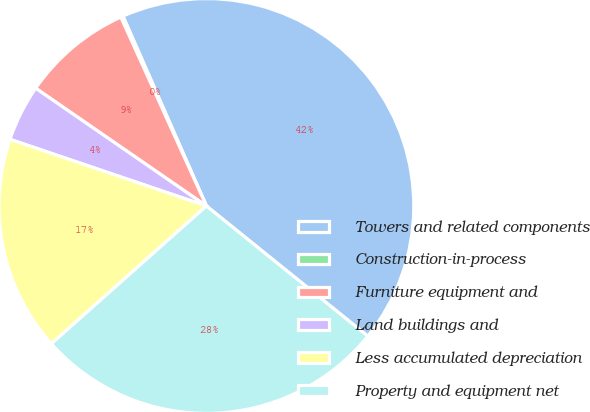Convert chart to OTSL. <chart><loc_0><loc_0><loc_500><loc_500><pie_chart><fcel>Towers and related components<fcel>Construction-in-process<fcel>Furniture equipment and<fcel>Land buildings and<fcel>Less accumulated depreciation<fcel>Property and equipment net<nl><fcel>42.39%<fcel>0.18%<fcel>8.62%<fcel>4.4%<fcel>16.77%<fcel>27.63%<nl></chart> 